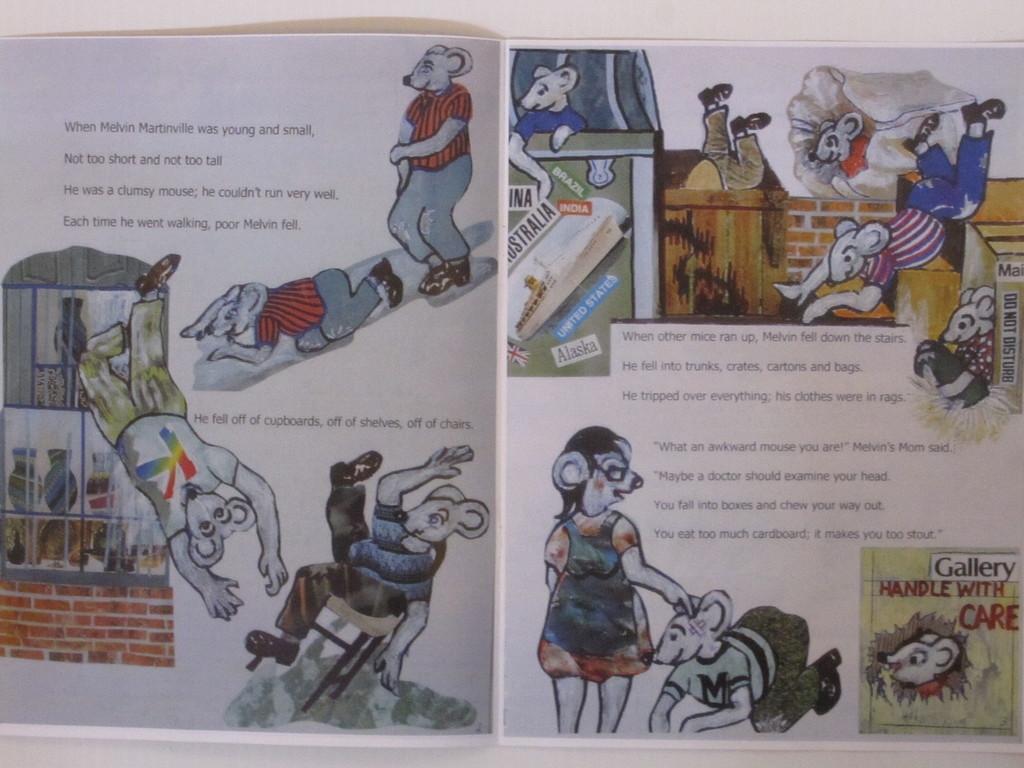What u.s. state is listed?
Provide a short and direct response. Alaska. 